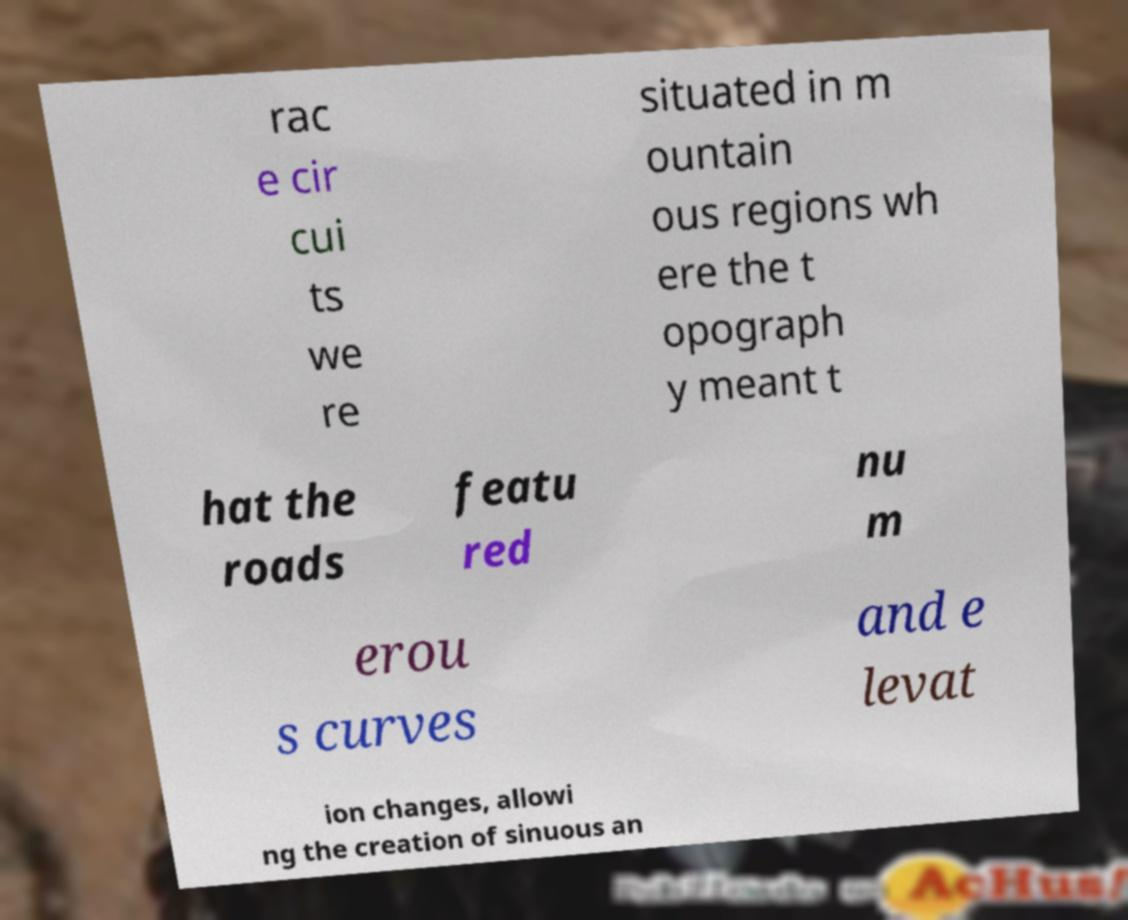For documentation purposes, I need the text within this image transcribed. Could you provide that? rac e cir cui ts we re situated in m ountain ous regions wh ere the t opograph y meant t hat the roads featu red nu m erou s curves and e levat ion changes, allowi ng the creation of sinuous an 